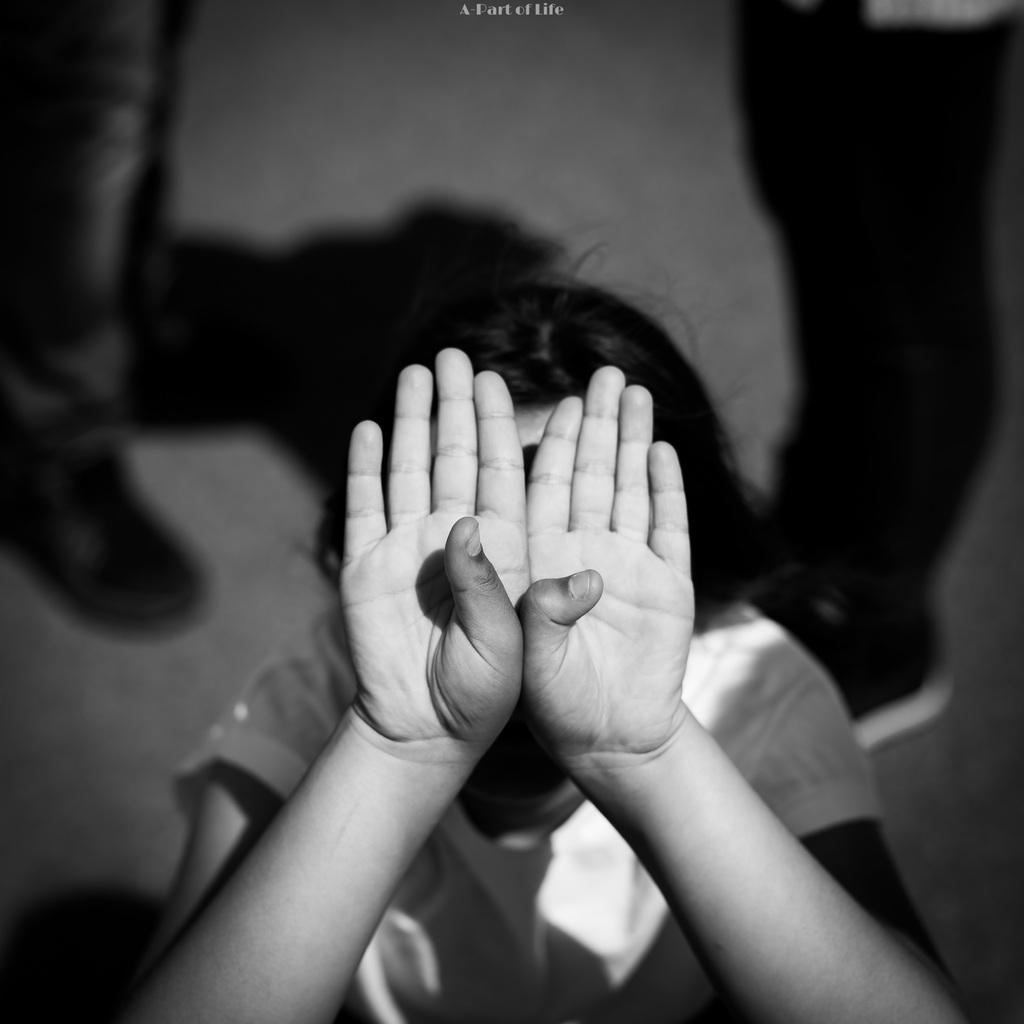What is the color scheme of the image? The image is black and white. Can you describe the people in the background? There are two persons standing in the background. Where are the persons standing? The persons are standing on the floor. What is the main subject in the middle of the image? There is a kid in the middle of the image. What is the kid doing in the image? The kid is covering their face with their hands. What type of sail can be seen in the image? There is no sail present in the image. Can you tell me the relationship between the kid and the person standing in the background? The provided facts do not give information about the relationship between the kid and the person standing in the background. 